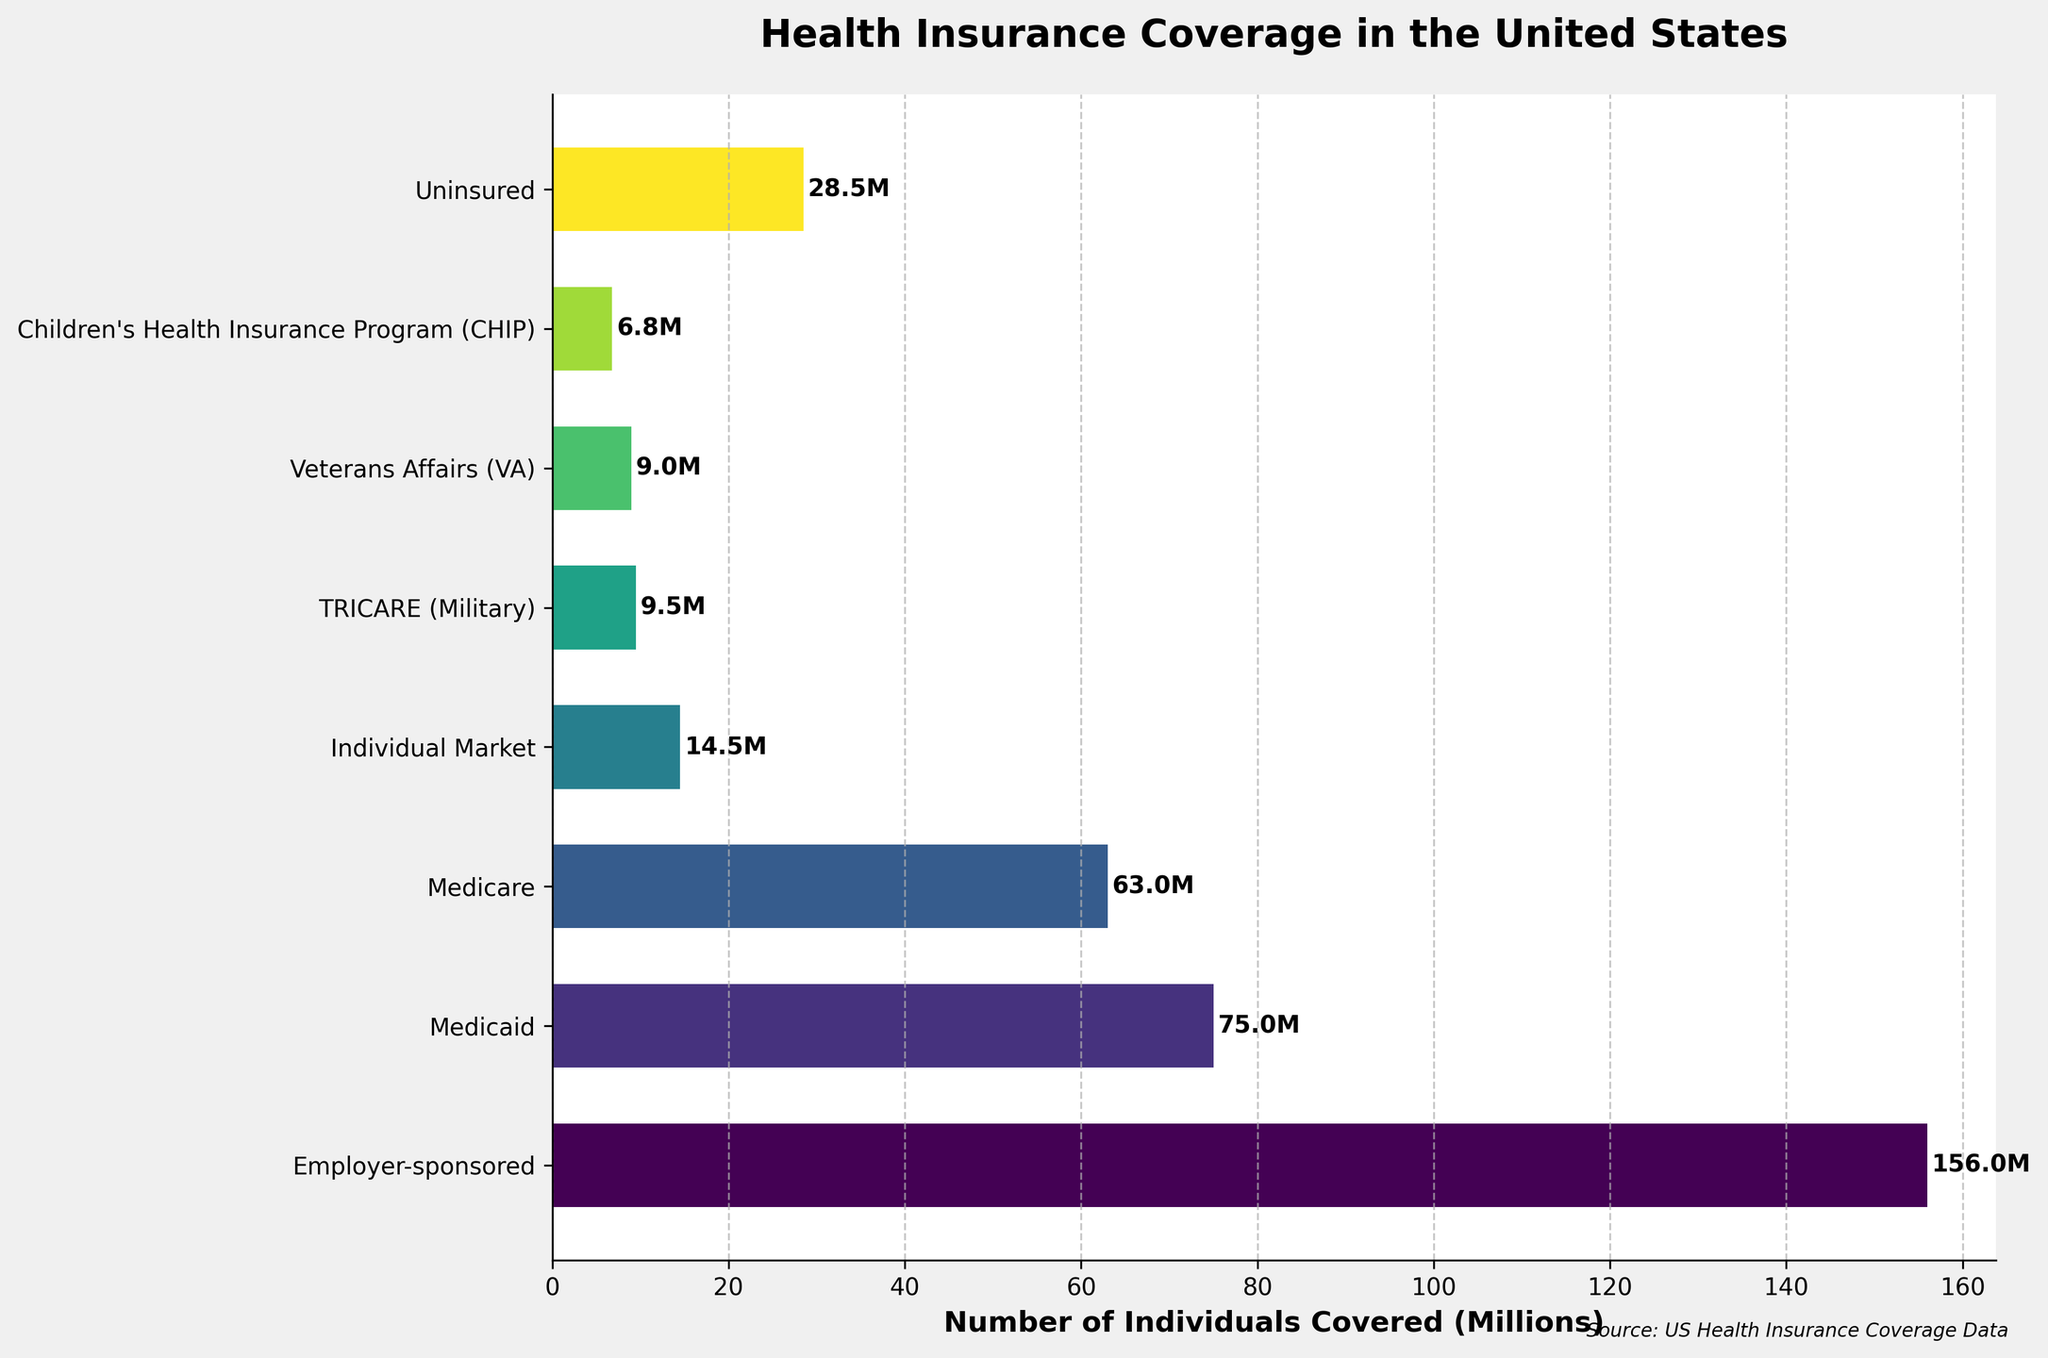How many more individuals are covered by Employer-sponsored insurance compared to Medicare? Look at the bars representing Employer-sponsored insurance and Medicare. The Employer-sponsored bar is labeled 156 million, and the Medicare bar is labeled 63 million. The difference is 156 million - 63 million.
Answer: 93 million Which insurance type covers fewer individuals, TRICARE or Children's Health Insurance Program (CHIP)? Locate the bars for TRICARE and CHIP. TRICARE covers 9.5 million, and CHIP covers 6.8 million. Compare the two numbers.
Answer: CHIP If you combine the number of individuals covered by Medicaid, Medicare, and the Individual Market, what is the total? Sum the values for Medicaid (75 million), Medicare (63 million), and Individual Market (14.5 million). Calculate 75 million + 63 million + 14.5 million.
Answer: 152.5 million Is the number of uninsured individuals higher or lower than the number covered by Medicaid? Compare the bar representing uninsured individuals (28.5 million) with the bar for Medicaid (75 million). The uninsured bar is shorter.
Answer: Lower Among the listed insurance types, which one has the highest coverage? Identify the bar with the longest length. The Employer-sponsored insurance bar is the longest and is labeled 156 million.
Answer: Employer-sponsored What is the sum of individuals covered by TRICARE and Veterans Affairs (VA)? Add the numbers for TRICARE (9.5 million) and VA (9 million). Calculate 9.5 million + 9 million.
Answer: 18.5 million Which is the smallest group in terms of the number of individuals covered? Find the bar with the shortest length. The CHIP bar is the shortest and is labeled 6.8 million.
Answer: CHIP What fraction of the total number of individuals covered does the Individual Market represent? First, find the total number covered by adding all values: 156 million + 75 million + 63 million + 14.5 million + 9.5 million + 9 million + 6.8 million = 333.8 million. Then, divide the Individual Market worth 14.5 million by the total: 14.5/333.8.
Answer: Approx. 0.0434 Compare the coverage of Medicaid and Medicare. Which has higher coverage? Look at the bars for Medicaid (75 million) and Medicare (63 million). The Medicaid bar is longer.
Answer: Medicaid How many individuals are covered by Employer-sponsored, Medicaid, and Medicare combined? Add the values for Employer-sponsored (156 million), Medicaid (75 million), and Medicare (63 million). Calculate 156 million + 75 million + 63 million.
Answer: 294 million 